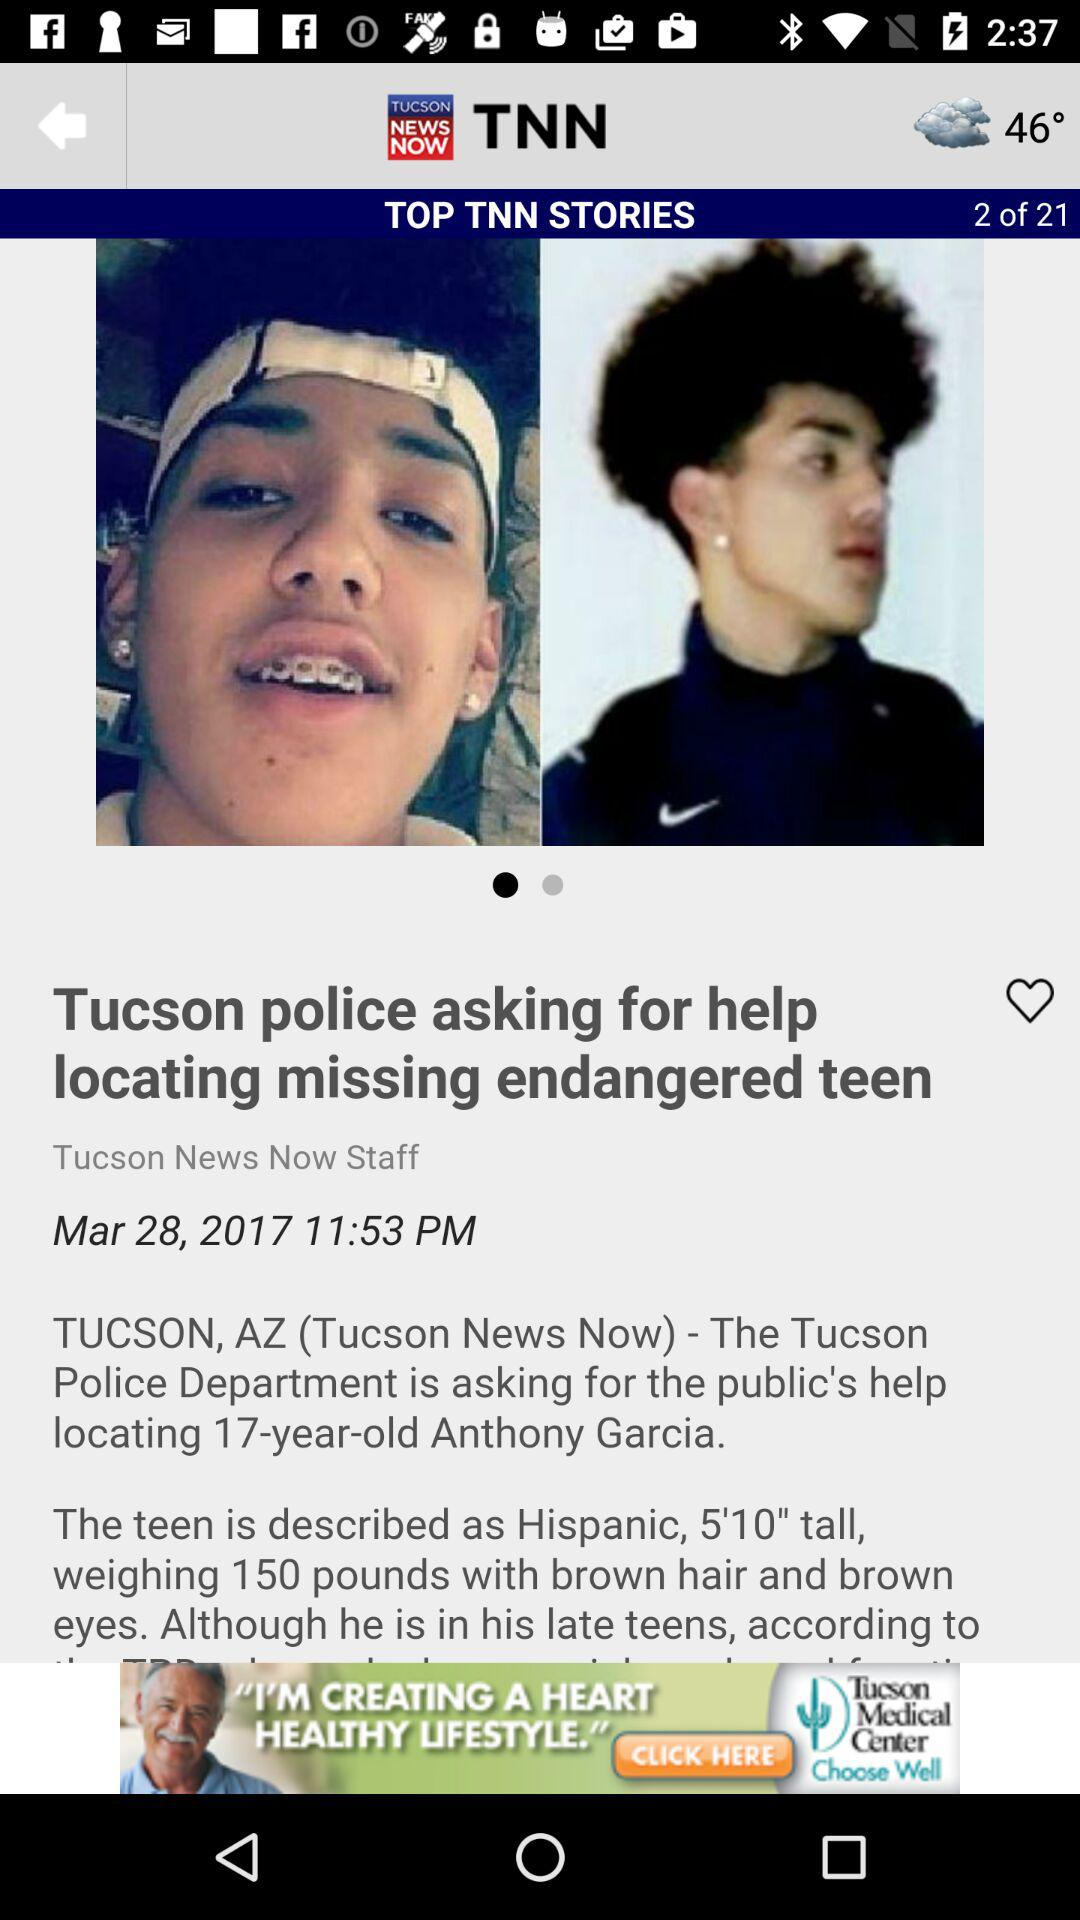What body features does Anthony Garcia have? Anthony Garcia is 5 feet 10 inches tall, weighs 150 pounds and has brown hair and brown eyes. 